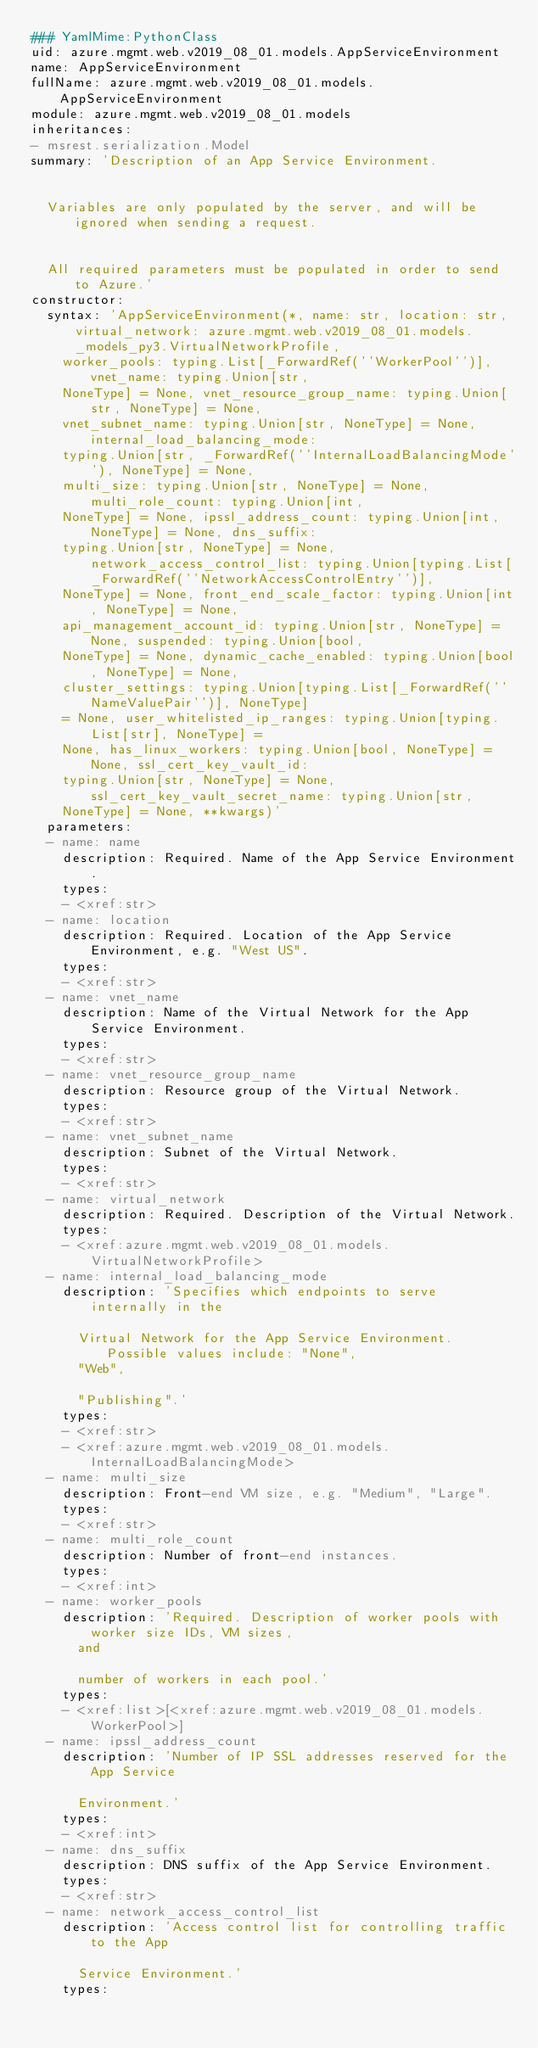Convert code to text. <code><loc_0><loc_0><loc_500><loc_500><_YAML_>### YamlMime:PythonClass
uid: azure.mgmt.web.v2019_08_01.models.AppServiceEnvironment
name: AppServiceEnvironment
fullName: azure.mgmt.web.v2019_08_01.models.AppServiceEnvironment
module: azure.mgmt.web.v2019_08_01.models
inheritances:
- msrest.serialization.Model
summary: 'Description of an App Service Environment.


  Variables are only populated by the server, and will be ignored when sending a request.


  All required parameters must be populated in order to send to Azure.'
constructor:
  syntax: 'AppServiceEnvironment(*, name: str, location: str, virtual_network: azure.mgmt.web.v2019_08_01.models._models_py3.VirtualNetworkProfile,
    worker_pools: typing.List[_ForwardRef(''WorkerPool'')], vnet_name: typing.Union[str,
    NoneType] = None, vnet_resource_group_name: typing.Union[str, NoneType] = None,
    vnet_subnet_name: typing.Union[str, NoneType] = None, internal_load_balancing_mode:
    typing.Union[str, _ForwardRef(''InternalLoadBalancingMode''), NoneType] = None,
    multi_size: typing.Union[str, NoneType] = None, multi_role_count: typing.Union[int,
    NoneType] = None, ipssl_address_count: typing.Union[int, NoneType] = None, dns_suffix:
    typing.Union[str, NoneType] = None, network_access_control_list: typing.Union[typing.List[_ForwardRef(''NetworkAccessControlEntry'')],
    NoneType] = None, front_end_scale_factor: typing.Union[int, NoneType] = None,
    api_management_account_id: typing.Union[str, NoneType] = None, suspended: typing.Union[bool,
    NoneType] = None, dynamic_cache_enabled: typing.Union[bool, NoneType] = None,
    cluster_settings: typing.Union[typing.List[_ForwardRef(''NameValuePair'')], NoneType]
    = None, user_whitelisted_ip_ranges: typing.Union[typing.List[str], NoneType] =
    None, has_linux_workers: typing.Union[bool, NoneType] = None, ssl_cert_key_vault_id:
    typing.Union[str, NoneType] = None, ssl_cert_key_vault_secret_name: typing.Union[str,
    NoneType] = None, **kwargs)'
  parameters:
  - name: name
    description: Required. Name of the App Service Environment.
    types:
    - <xref:str>
  - name: location
    description: Required. Location of the App Service Environment, e.g. "West US".
    types:
    - <xref:str>
  - name: vnet_name
    description: Name of the Virtual Network for the App Service Environment.
    types:
    - <xref:str>
  - name: vnet_resource_group_name
    description: Resource group of the Virtual Network.
    types:
    - <xref:str>
  - name: vnet_subnet_name
    description: Subnet of the Virtual Network.
    types:
    - <xref:str>
  - name: virtual_network
    description: Required. Description of the Virtual Network.
    types:
    - <xref:azure.mgmt.web.v2019_08_01.models.VirtualNetworkProfile>
  - name: internal_load_balancing_mode
    description: 'Specifies which endpoints to serve internally in the

      Virtual Network for the App Service Environment. Possible values include: "None",
      "Web",

      "Publishing".'
    types:
    - <xref:str>
    - <xref:azure.mgmt.web.v2019_08_01.models.InternalLoadBalancingMode>
  - name: multi_size
    description: Front-end VM size, e.g. "Medium", "Large".
    types:
    - <xref:str>
  - name: multi_role_count
    description: Number of front-end instances.
    types:
    - <xref:int>
  - name: worker_pools
    description: 'Required. Description of worker pools with worker size IDs, VM sizes,
      and

      number of workers in each pool.'
    types:
    - <xref:list>[<xref:azure.mgmt.web.v2019_08_01.models.WorkerPool>]
  - name: ipssl_address_count
    description: 'Number of IP SSL addresses reserved for the App Service

      Environment.'
    types:
    - <xref:int>
  - name: dns_suffix
    description: DNS suffix of the App Service Environment.
    types:
    - <xref:str>
  - name: network_access_control_list
    description: 'Access control list for controlling traffic to the App

      Service Environment.'
    types:</code> 